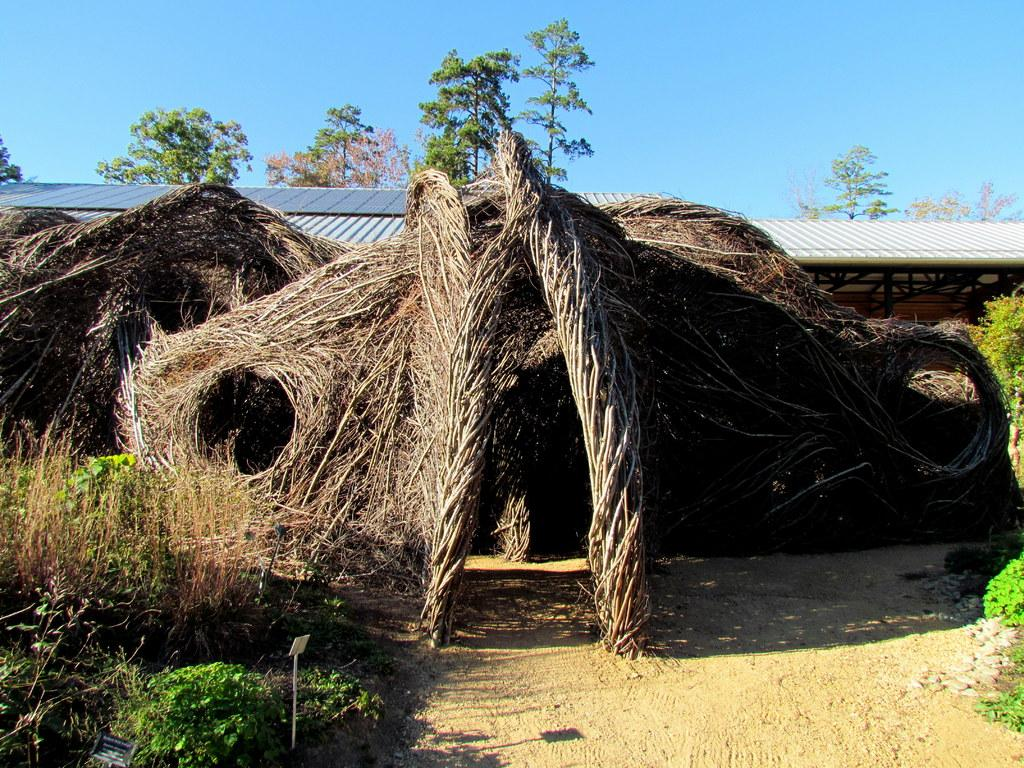What type of vegetation is in front of the tent house in the image? There is grass in front of the tent house in the image. What other natural elements can be seen in the image? There are trees visible in the image. What is visible at the top of the image? The sky is visible at the top of the image. Is there a volcano visible in the image? No, there is no volcano present in the image. What type of friction can be seen between the grass and the tent house? There is no friction visible between the grass and the tent house in the image. 